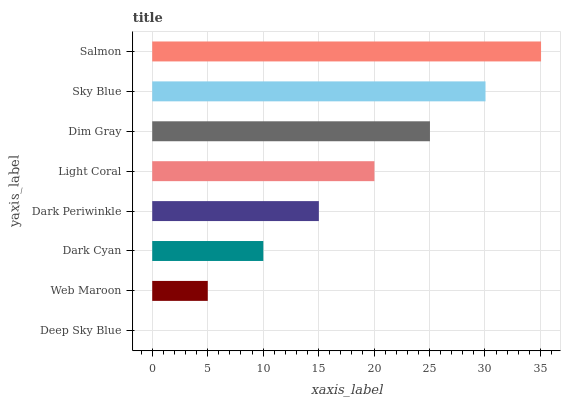Is Deep Sky Blue the minimum?
Answer yes or no. Yes. Is Salmon the maximum?
Answer yes or no. Yes. Is Web Maroon the minimum?
Answer yes or no. No. Is Web Maroon the maximum?
Answer yes or no. No. Is Web Maroon greater than Deep Sky Blue?
Answer yes or no. Yes. Is Deep Sky Blue less than Web Maroon?
Answer yes or no. Yes. Is Deep Sky Blue greater than Web Maroon?
Answer yes or no. No. Is Web Maroon less than Deep Sky Blue?
Answer yes or no. No. Is Light Coral the high median?
Answer yes or no. Yes. Is Dark Periwinkle the low median?
Answer yes or no. Yes. Is Deep Sky Blue the high median?
Answer yes or no. No. Is Light Coral the low median?
Answer yes or no. No. 